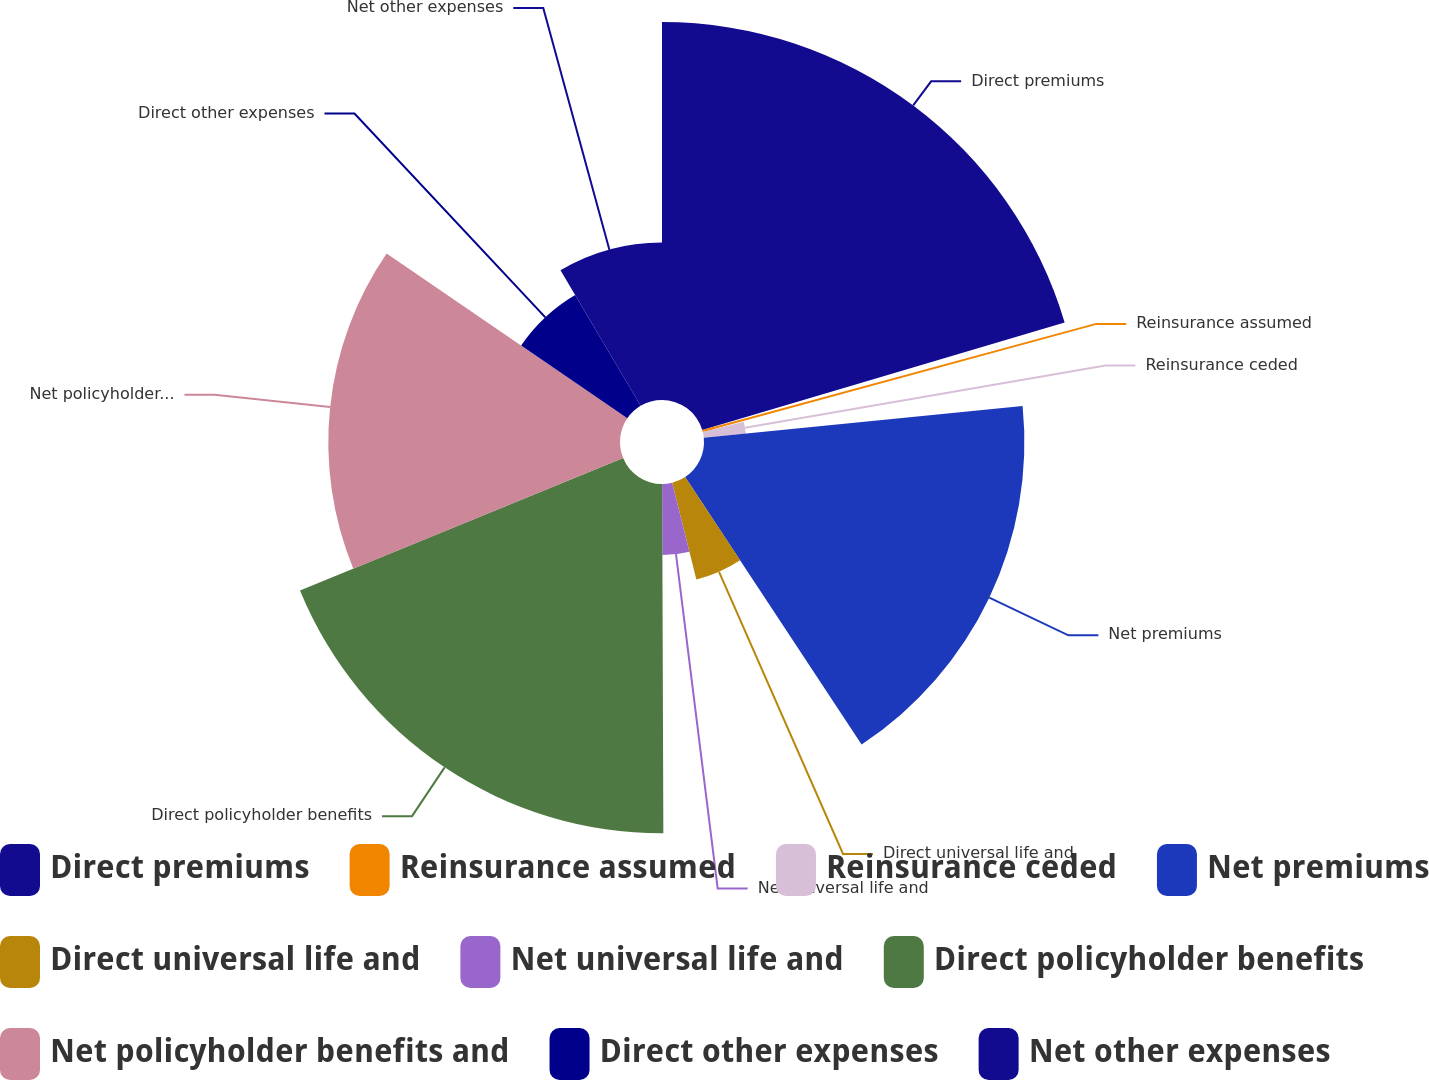Convert chart to OTSL. <chart><loc_0><loc_0><loc_500><loc_500><pie_chart><fcel>Direct premiums<fcel>Reinsurance assumed<fcel>Reinsurance ceded<fcel>Net premiums<fcel>Direct universal life and<fcel>Net universal life and<fcel>Direct policyholder benefits<fcel>Net policyholder benefits and<fcel>Direct other expenses<fcel>Net other expenses<nl><fcel>20.41%<fcel>0.73%<fcel>2.28%<fcel>17.3%<fcel>5.39%<fcel>3.84%<fcel>18.86%<fcel>15.75%<fcel>6.95%<fcel>8.5%<nl></chart> 